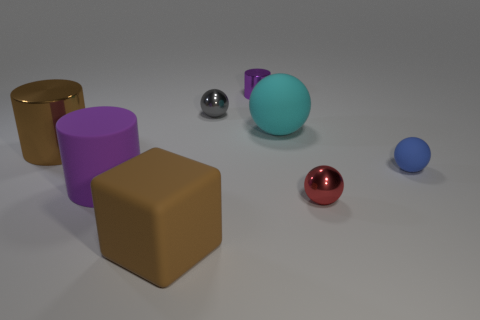There is a metallic cylinder that is in front of the large cyan thing; is its size the same as the metallic sphere in front of the purple rubber thing? After observing the image, the metallic cylinder in front of the large cyan object is larger in both height and diameter compared to the metallic sphere in front of the purple object, which appears to be made of rubber. 